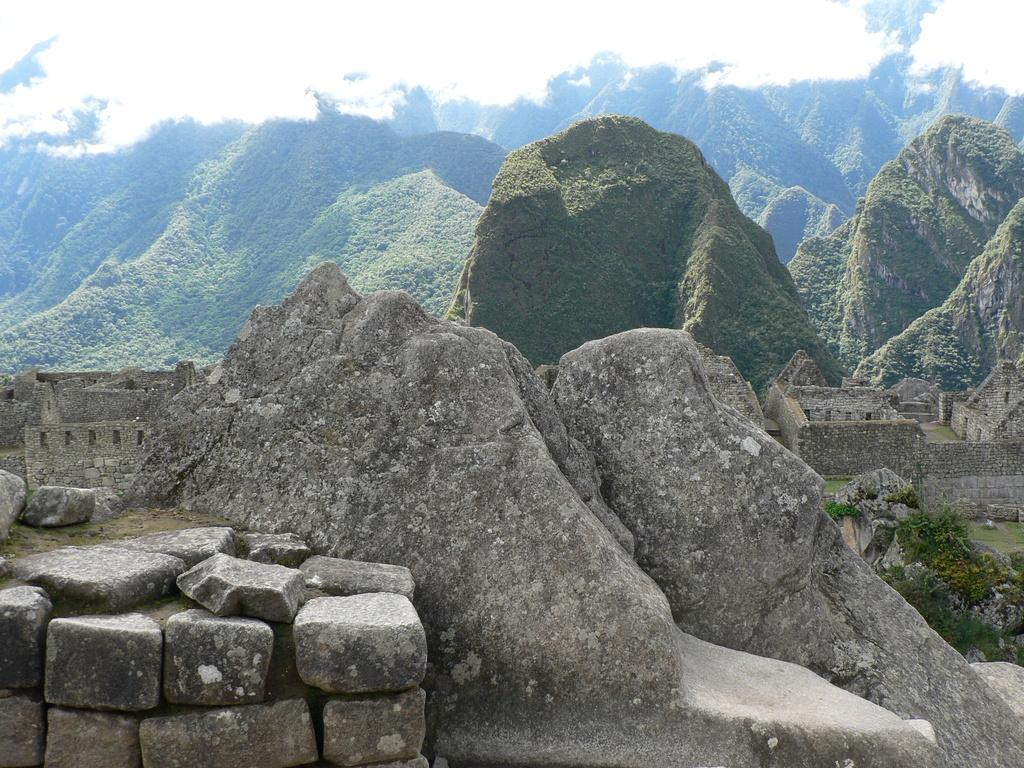What type of natural elements can be seen in the image? There are stones in the image. What type of landscape is visible in the background of the image? There are mountains in the background of the image. What is the condition of the sky in the background of the image? The sky is clear in the background of the image. What type of reading material is visible on the dock in the image? There is no dock or reading material present in the image. How does the society depicted in the image interact with the stones? There is no society depicted in the image, and therefore no interaction with the stones can be observed. 